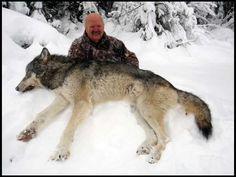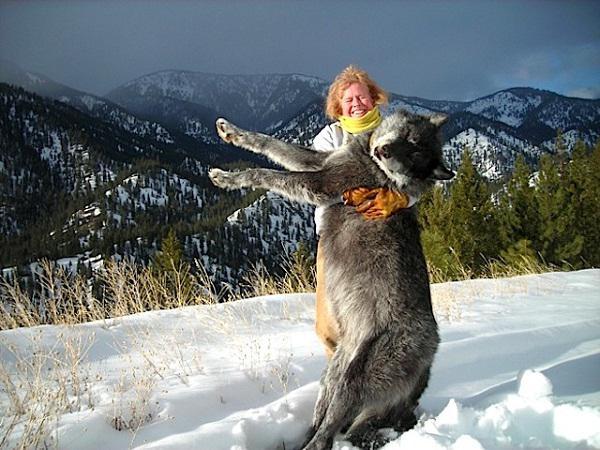The first image is the image on the left, the second image is the image on the right. Assess this claim about the two images: "One image shows a nonstanding person posed behind a reclining wolf, and the other other image shows a standing person with arms holding up a wolf.". Correct or not? Answer yes or no. Yes. 